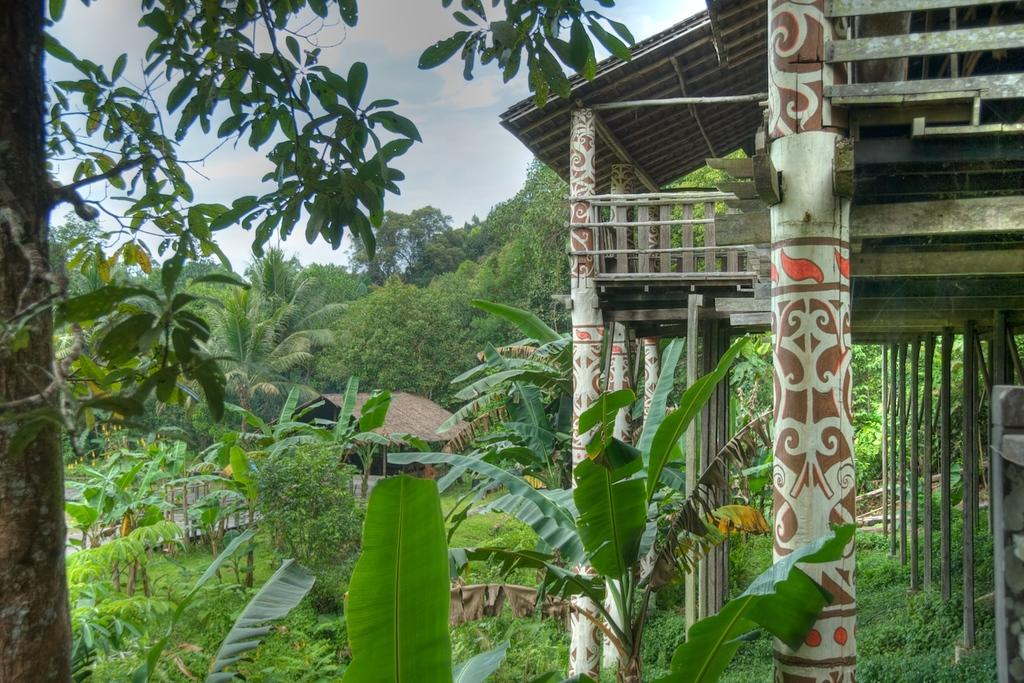What type of vegetation can be seen in the image? There are trees and plants in the image. What type of structure is visible in the image? There is a house in the image. Can you describe the structure on the right side of the image? There is a shed with pillars on the right side of the image. What is visible in the background of the image? The sky is visible in the background of the image. What type of expansion is being carried out on the house in the image? There is no indication of any expansion being carried out on the house in the image. Can you see a yoke attached to the trees in the image? There is no yoke present in the image; it features trees, plants, a house, and a shed with pillars. 